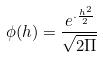Convert formula to latex. <formula><loc_0><loc_0><loc_500><loc_500>\phi ( h ) = \frac { e ^ { \cdot \frac { h ^ { 2 } } { 2 } } } { \sqrt { 2 \Pi } }</formula> 